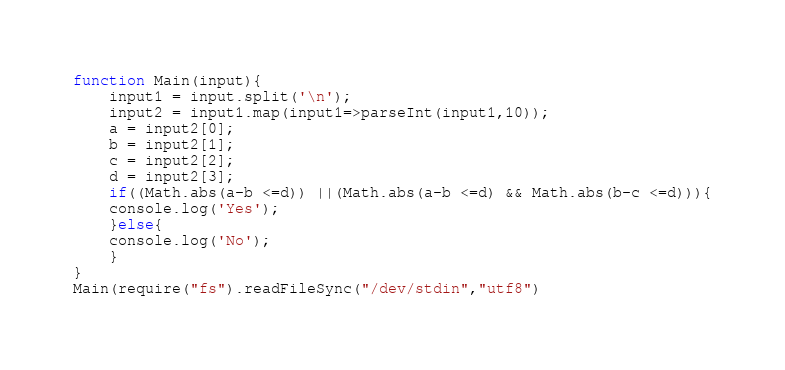<code> <loc_0><loc_0><loc_500><loc_500><_JavaScript_>function Main(input){
	input1 = input.split('\n');
    input2 = input1.map(input1=>parseInt(input1,10));
    a = input2[0];
    b = input2[1];
    c = input2[2];
    d = input2[3];
    if((Math.abs(a-b <=d)) ||(Math.abs(a-b <=d) && Math.abs(b-c <=d))){
    console.log('Yes');
    }else{
    console.log('No');
    }
}
Main(require("fs").readFileSync("/dev/stdin","utf8")</code> 